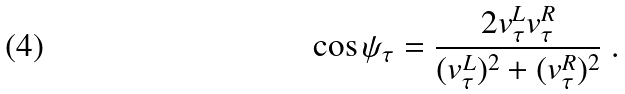Convert formula to latex. <formula><loc_0><loc_0><loc_500><loc_500>\cos \psi _ { \tau } = \frac { 2 v ^ { L } _ { \tau } v ^ { R } _ { \tau } } { ( v ^ { L } _ { \tau } ) ^ { 2 } + ( v ^ { R } _ { \tau } ) ^ { 2 } } \ .</formula> 